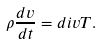<formula> <loc_0><loc_0><loc_500><loc_500>\rho \frac { d v } { d t } = d i v T .</formula> 